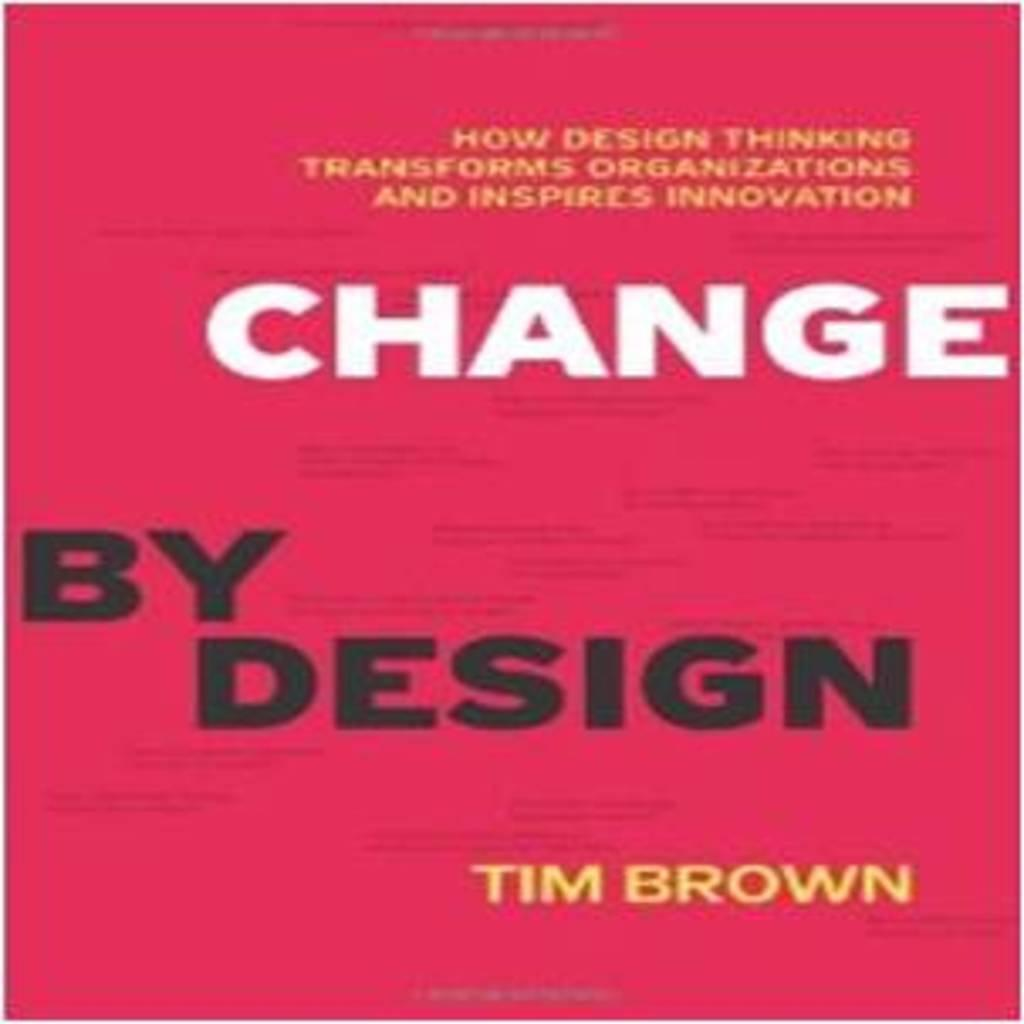<image>
Render a clear and concise summary of the photo. Change by Design has a red cover with yellow writing. 